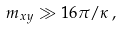<formula> <loc_0><loc_0><loc_500><loc_500>m _ { x y } \gg 1 6 \pi / \kappa \, ,</formula> 